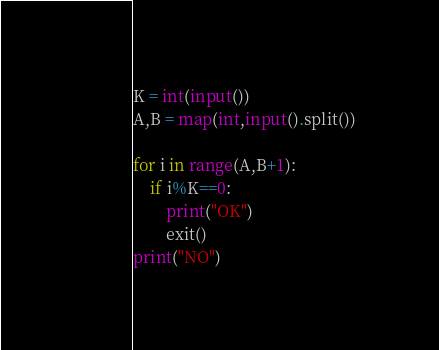Convert code to text. <code><loc_0><loc_0><loc_500><loc_500><_Python_>K = int(input())
A,B = map(int,input().split())

for i in range(A,B+1):
    if i%K==0:
        print("OK")
        exit()
print("NO")</code> 